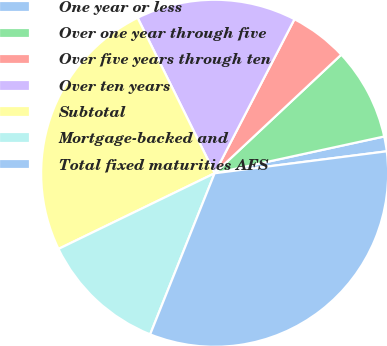<chart> <loc_0><loc_0><loc_500><loc_500><pie_chart><fcel>One year or less<fcel>Over one year through five<fcel>Over five years through ten<fcel>Over ten years<fcel>Subtotal<fcel>Mortgage-backed and<fcel>Total fixed maturities AFS<nl><fcel>1.38%<fcel>8.58%<fcel>5.41%<fcel>14.93%<fcel>24.86%<fcel>11.76%<fcel>33.08%<nl></chart> 